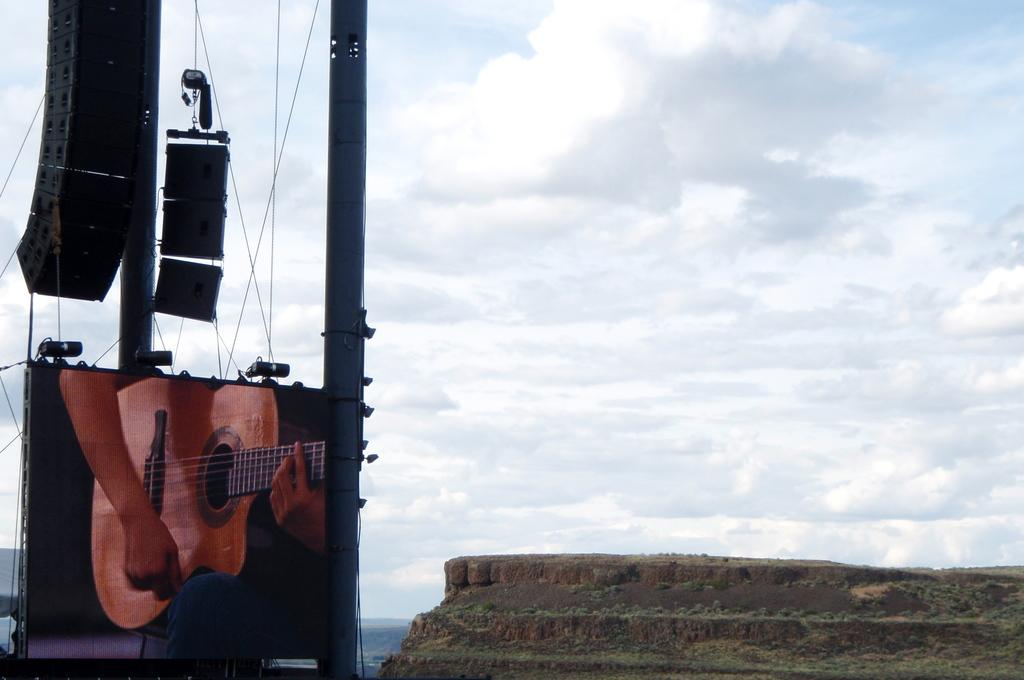What is located on the left side of the image? There is a pole, a screen, lights, speakers, and wires on the left side of the image. What can be seen in the background of the image? There is a hill, water, sky, and clouds visible in the background of the image. Can you tell me how many worms are crawling on the plate in the image? There is no plate or worms present in the image. What type of rhythm is being played by the speakers in the image? The image does not provide information about the type of rhythm being played by the speakers. 